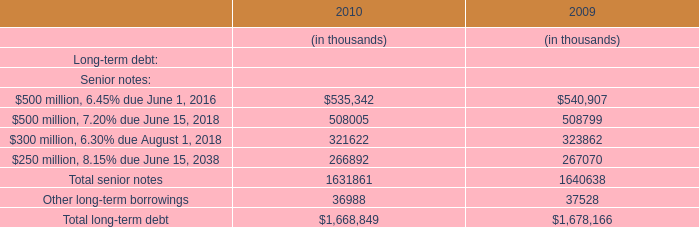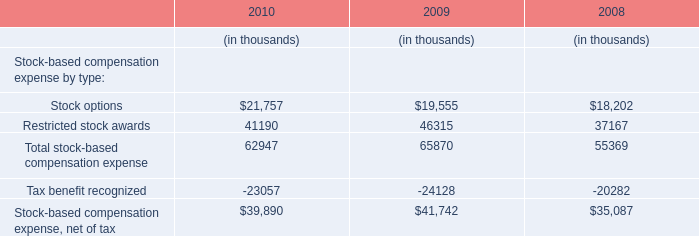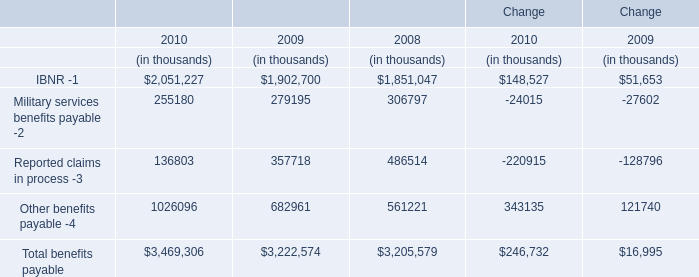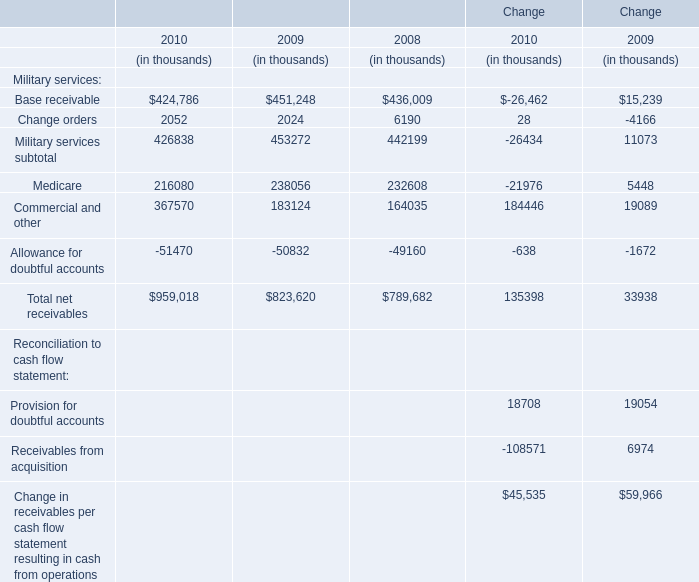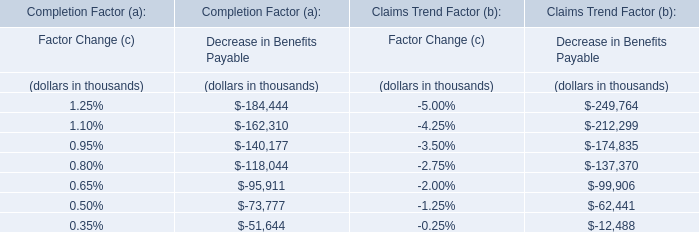What is the sum of Base receivable, Change orders and Medicare in 2010? (in thousand) 
Computations: ((424786 + 2052) + 216080)
Answer: 642918.0. 